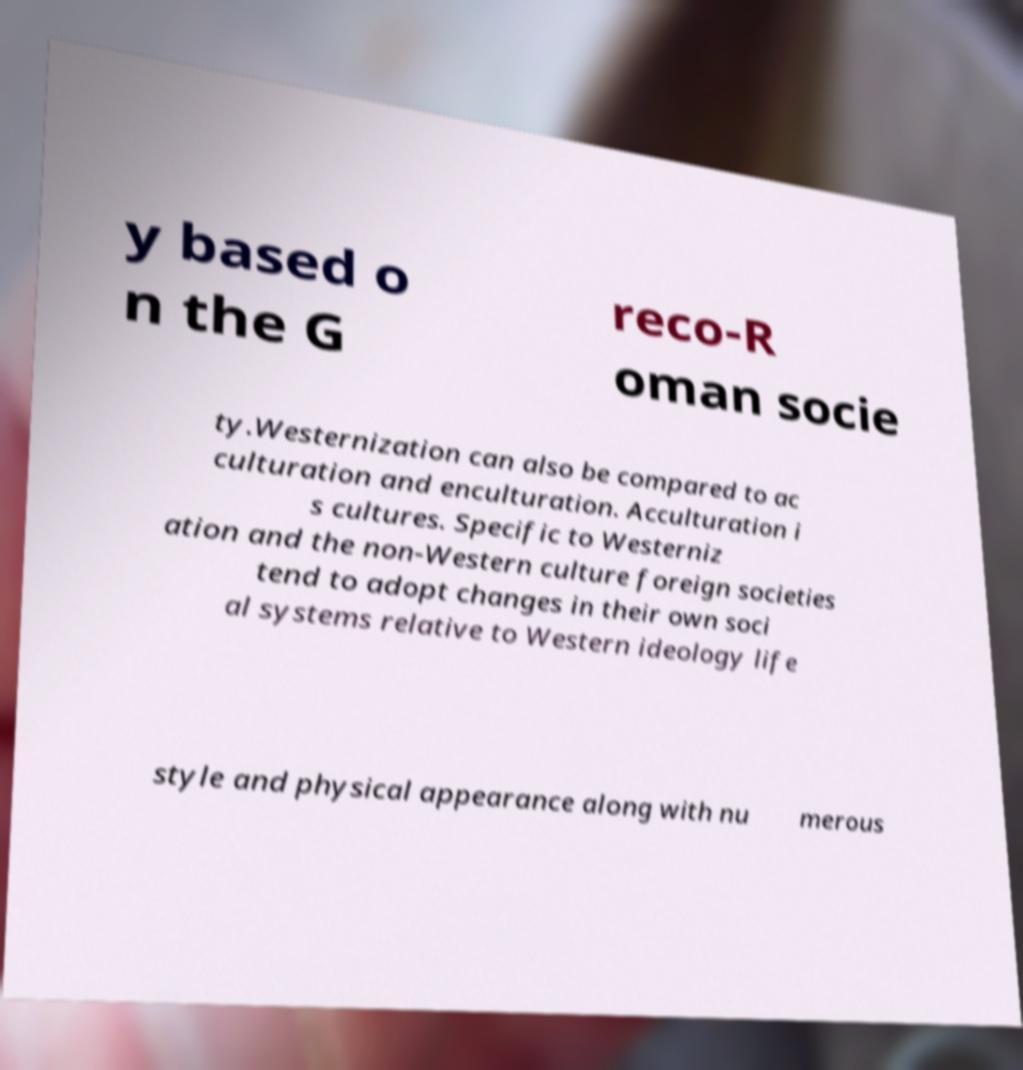There's text embedded in this image that I need extracted. Can you transcribe it verbatim? y based o n the G reco-R oman socie ty.Westernization can also be compared to ac culturation and enculturation. Acculturation i s cultures. Specific to Westerniz ation and the non-Western culture foreign societies tend to adopt changes in their own soci al systems relative to Western ideology life style and physical appearance along with nu merous 